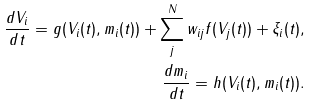Convert formula to latex. <formula><loc_0><loc_0><loc_500><loc_500>\frac { d V _ { i } } { d t } = g ( V _ { i } ( t ) , m _ { i } ( t ) ) + \sum _ { j } ^ { N } w _ { i j } f ( V _ { j } ( t ) ) + \xi _ { i } ( t ) , \\ \frac { d m _ { i } } { d t } = h ( V _ { i } ( t ) , m _ { i } ( t ) ) .</formula> 